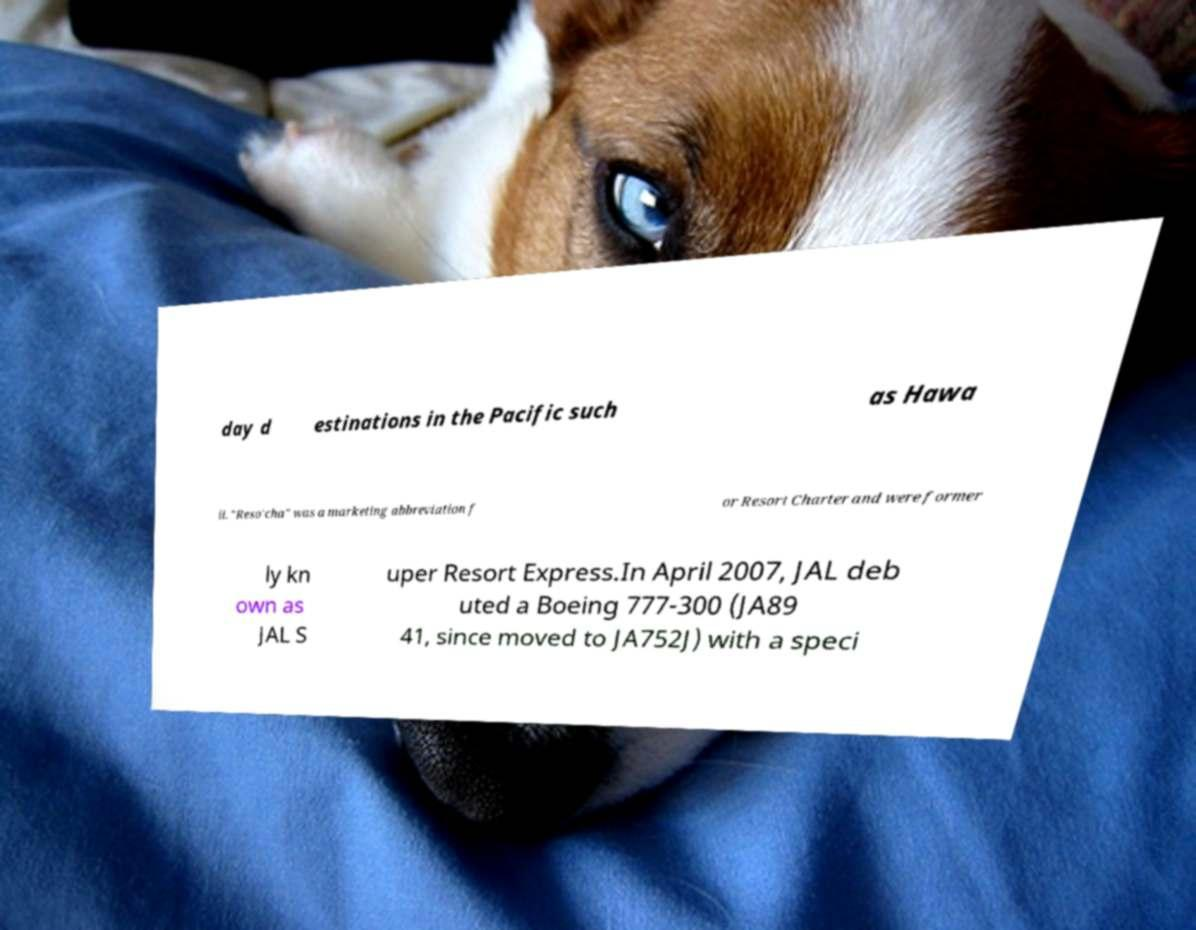Can you accurately transcribe the text from the provided image for me? day d estinations in the Pacific such as Hawa ii. "Reso'cha" was a marketing abbreviation f or Resort Charter and were former ly kn own as JAL S uper Resort Express.In April 2007, JAL deb uted a Boeing 777-300 (JA89 41, since moved to JA752J) with a speci 